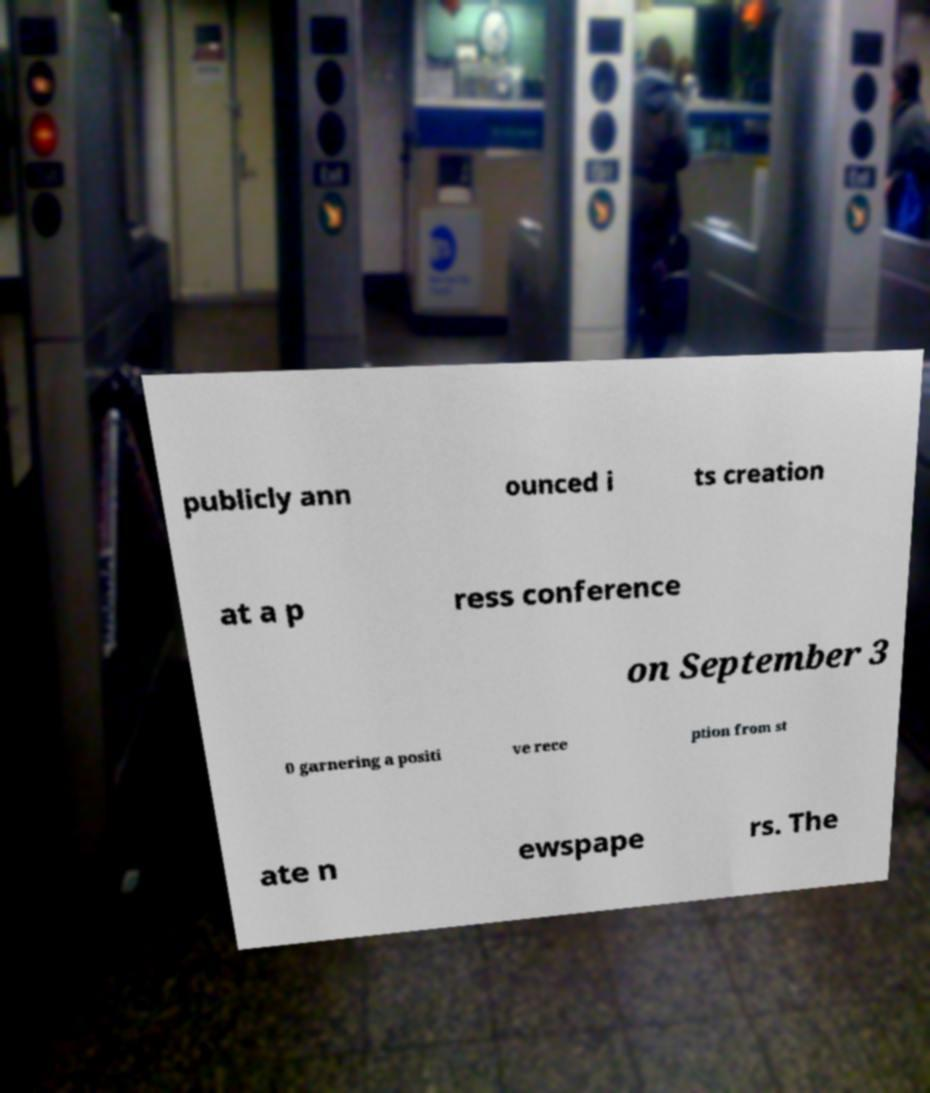There's text embedded in this image that I need extracted. Can you transcribe it verbatim? publicly ann ounced i ts creation at a p ress conference on September 3 0 garnering a positi ve rece ption from st ate n ewspape rs. The 